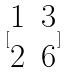<formula> <loc_0><loc_0><loc_500><loc_500>[ \begin{matrix} 1 & 3 \\ 2 & 6 \end{matrix} ]</formula> 